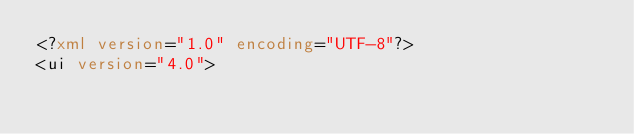Convert code to text. <code><loc_0><loc_0><loc_500><loc_500><_XML_><?xml version="1.0" encoding="UTF-8"?>
<ui version="4.0"></code> 